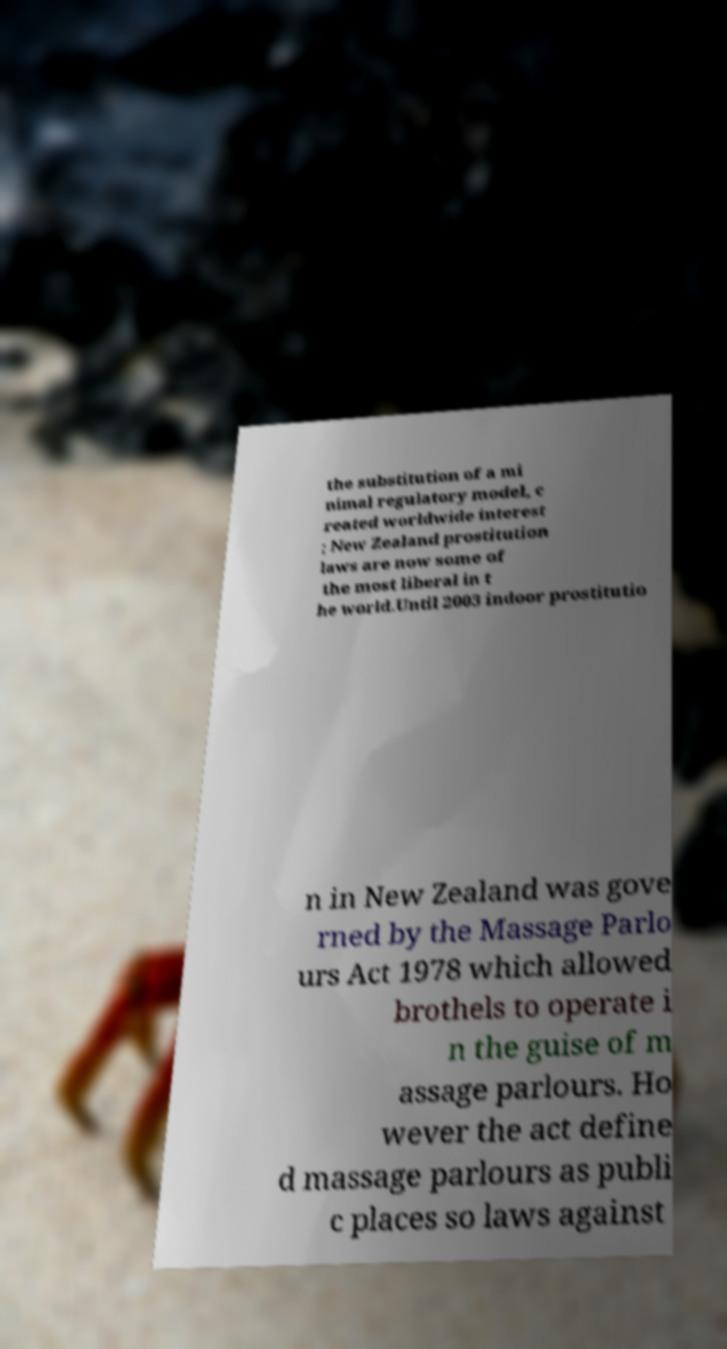Could you assist in decoding the text presented in this image and type it out clearly? the substitution of a mi nimal regulatory model, c reated worldwide interest ; New Zealand prostitution laws are now some of the most liberal in t he world.Until 2003 indoor prostitutio n in New Zealand was gove rned by the Massage Parlo urs Act 1978 which allowed brothels to operate i n the guise of m assage parlours. Ho wever the act define d massage parlours as publi c places so laws against 